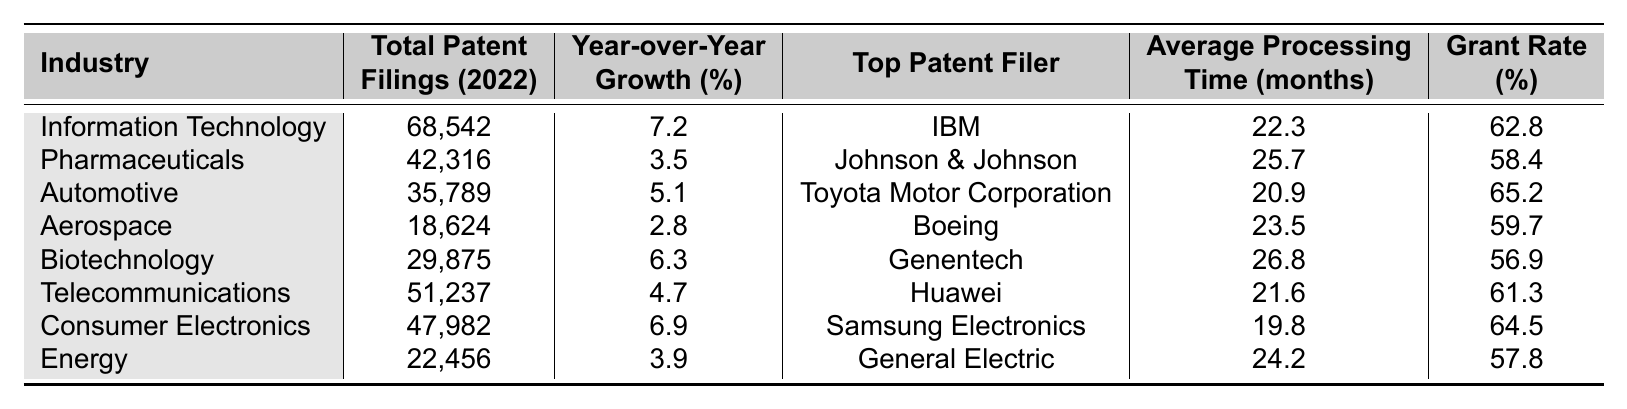What industry had the highest total patent filings in 2022? By reviewing the "Total Patent Filings (2022)" column, we can see that "Information Technology" has the highest value listed, which is 68,542.
Answer: Information Technology What is the grant rate for the pharmaceutical industry? Looking at the "Grant Rate (%)" column for the "Pharmaceuticals" row, the value is 58.4.
Answer: 58.4 Which industry showed a year-over-year growth of 4.7%? In the "Year-over-Year Growth (%)" column, we find that "Telecommunications" has the value of 4.7%.
Answer: Telecommunications How many months on average does it take to process a patent application in the automotive industry? By checking the "Average Processing Time (months)" column for the "Automotive" row, it shows 20.9 months.
Answer: 20.9 months What is the difference in total patent filings between the information technology and aerospace industries? The total patent filings for "Information Technology" is 68,542 and for "Aerospace" it is 18,624. The difference is 68,542 - 18,624 = 49,918.
Answer: 49,918 Which top patent filer has the longest average processing time? Comparing the "Average Processing Time (months)" for all top patent filers, Genentech's 26.8 months is the highest.
Answer: Genentech What percentage of grant rate is there for the biotechnology industry? Checking the "Grant Rate (%)" column under the "Biotechnology" row, we find it is 56.9%.
Answer: 56.9% Is the year-over-year growth for consumer electronics higher than that for the energy sector? The year-over-year growth for "Consumer Electronics" is 6.9% and for "Energy" it is 3.9%. Since 6.9% is greater, the statement is true.
Answer: Yes What is the average grant rate for the industries listed in the table? Adding the grant rates (62.8 + 58.4 + 65.2 + 59.7 + 56.9 + 61.3 + 64.5 + 57.8 = 406.6) and dividing by the number of industries (8) gives the average: 406.6 / 8 = 50.825.
Answer: 50.825 Which industry has the top patent filer as Boeing, and what is its year-over-year growth percentage? "Aerospace" is the industry with Boeing as the top patent filer, and its year-over-year growth percentage is 2.8%.
Answer: Aerospace, 2.8% 